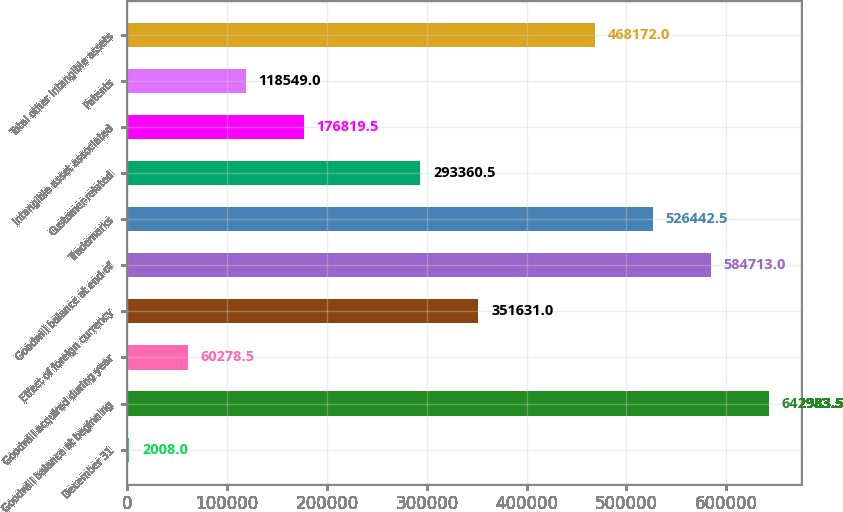Convert chart. <chart><loc_0><loc_0><loc_500><loc_500><bar_chart><fcel>December 31<fcel>Goodwill balance at beginning<fcel>Goodwill acquired during year<fcel>Effect of foreign currency<fcel>Goodwill balance at end of<fcel>Trademarks<fcel>Customer-related<fcel>Intangible asset associated<fcel>Patents<fcel>Total other intangible assets<nl><fcel>2008<fcel>642984<fcel>60278.5<fcel>351631<fcel>584713<fcel>526442<fcel>293360<fcel>176820<fcel>118549<fcel>468172<nl></chart> 